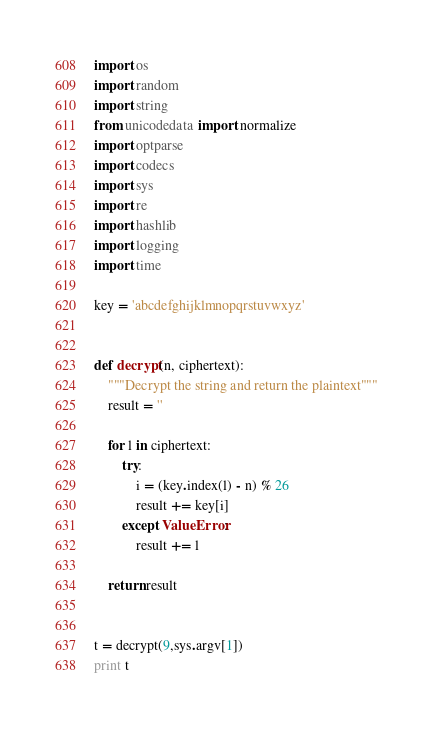<code> <loc_0><loc_0><loc_500><loc_500><_Python_>import os
import random
import string
from unicodedata import normalize
import optparse
import codecs
import sys
import re
import hashlib
import logging
import time

key = 'abcdefghijklmnopqrstuvwxyz'


def decrypt(n, ciphertext):
    """Decrypt the string and return the plaintext"""
    result = ''

    for l in ciphertext:
        try:
            i = (key.index(l) - n) % 26
            result += key[i]
        except ValueError:
            result += l

    return result


t = decrypt(9,sys.argv[1])
print t
</code> 